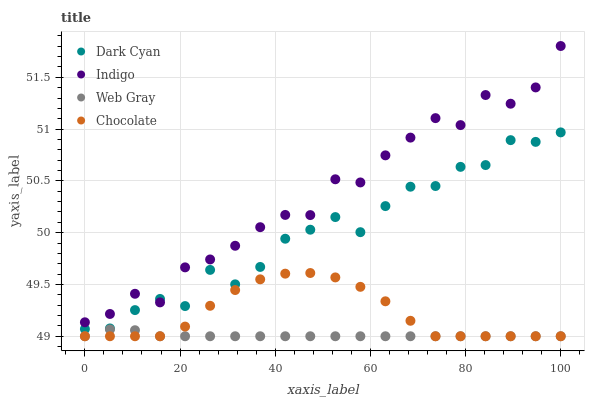Does Web Gray have the minimum area under the curve?
Answer yes or no. Yes. Does Indigo have the maximum area under the curve?
Answer yes or no. Yes. Does Indigo have the minimum area under the curve?
Answer yes or no. No. Does Web Gray have the maximum area under the curve?
Answer yes or no. No. Is Web Gray the smoothest?
Answer yes or no. Yes. Is Indigo the roughest?
Answer yes or no. Yes. Is Indigo the smoothest?
Answer yes or no. No. Is Web Gray the roughest?
Answer yes or no. No. Does Web Gray have the lowest value?
Answer yes or no. Yes. Does Indigo have the lowest value?
Answer yes or no. No. Does Indigo have the highest value?
Answer yes or no. Yes. Does Web Gray have the highest value?
Answer yes or no. No. Is Web Gray less than Indigo?
Answer yes or no. Yes. Is Indigo greater than Chocolate?
Answer yes or no. Yes. Does Dark Cyan intersect Indigo?
Answer yes or no. Yes. Is Dark Cyan less than Indigo?
Answer yes or no. No. Is Dark Cyan greater than Indigo?
Answer yes or no. No. Does Web Gray intersect Indigo?
Answer yes or no. No. 